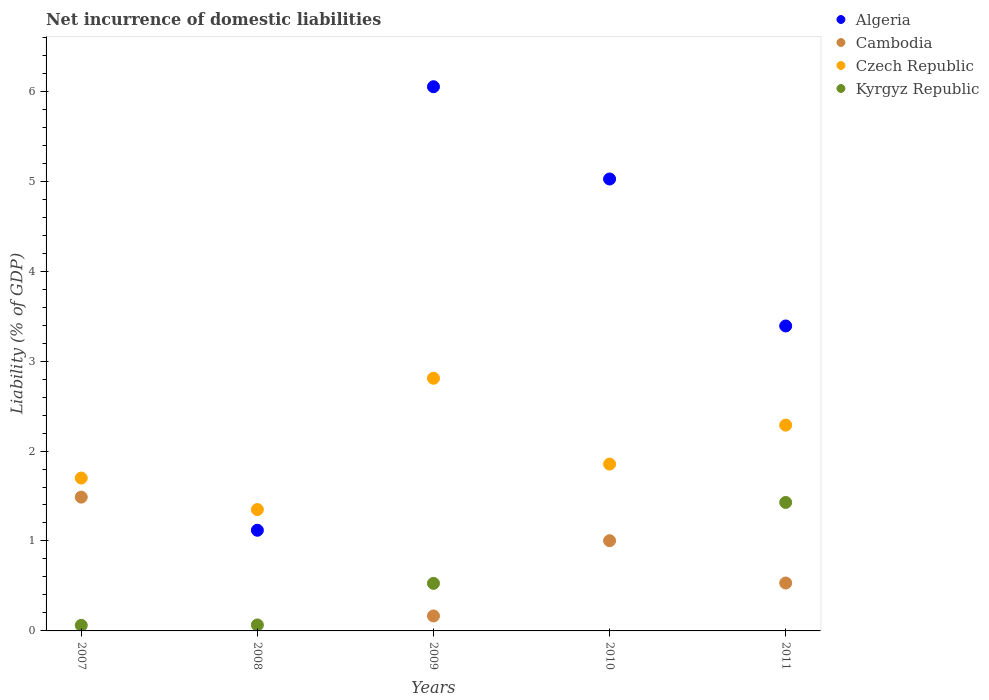How many different coloured dotlines are there?
Make the answer very short. 4. What is the net incurrence of domestic liabilities in Czech Republic in 2009?
Your response must be concise. 2.81. Across all years, what is the maximum net incurrence of domestic liabilities in Kyrgyz Republic?
Make the answer very short. 1.43. Across all years, what is the minimum net incurrence of domestic liabilities in Czech Republic?
Offer a very short reply. 1.35. In which year was the net incurrence of domestic liabilities in Algeria maximum?
Ensure brevity in your answer.  2009. What is the total net incurrence of domestic liabilities in Algeria in the graph?
Give a very brief answer. 15.58. What is the difference between the net incurrence of domestic liabilities in Cambodia in 2007 and that in 2009?
Offer a terse response. 1.32. What is the difference between the net incurrence of domestic liabilities in Kyrgyz Republic in 2008 and the net incurrence of domestic liabilities in Cambodia in 2009?
Offer a terse response. -0.1. What is the average net incurrence of domestic liabilities in Algeria per year?
Offer a very short reply. 3.12. In the year 2009, what is the difference between the net incurrence of domestic liabilities in Cambodia and net incurrence of domestic liabilities in Kyrgyz Republic?
Your answer should be very brief. -0.36. What is the ratio of the net incurrence of domestic liabilities in Cambodia in 2007 to that in 2011?
Make the answer very short. 2.79. What is the difference between the highest and the second highest net incurrence of domestic liabilities in Czech Republic?
Offer a terse response. 0.52. What is the difference between the highest and the lowest net incurrence of domestic liabilities in Cambodia?
Provide a short and direct response. 1.49. How many dotlines are there?
Your answer should be very brief. 4. How many years are there in the graph?
Keep it short and to the point. 5. Are the values on the major ticks of Y-axis written in scientific E-notation?
Provide a short and direct response. No. Does the graph contain any zero values?
Keep it short and to the point. Yes. What is the title of the graph?
Your answer should be very brief. Net incurrence of domestic liabilities. What is the label or title of the Y-axis?
Your answer should be very brief. Liability (% of GDP). What is the Liability (% of GDP) in Algeria in 2007?
Your answer should be very brief. 0. What is the Liability (% of GDP) of Cambodia in 2007?
Your answer should be compact. 1.49. What is the Liability (% of GDP) of Czech Republic in 2007?
Make the answer very short. 1.7. What is the Liability (% of GDP) in Kyrgyz Republic in 2007?
Provide a succinct answer. 0.06. What is the Liability (% of GDP) in Algeria in 2008?
Offer a terse response. 1.12. What is the Liability (% of GDP) in Cambodia in 2008?
Your answer should be compact. 0. What is the Liability (% of GDP) in Czech Republic in 2008?
Keep it short and to the point. 1.35. What is the Liability (% of GDP) in Kyrgyz Republic in 2008?
Your answer should be compact. 0.07. What is the Liability (% of GDP) of Algeria in 2009?
Provide a short and direct response. 6.05. What is the Liability (% of GDP) in Cambodia in 2009?
Make the answer very short. 0.17. What is the Liability (% of GDP) in Czech Republic in 2009?
Offer a terse response. 2.81. What is the Liability (% of GDP) in Kyrgyz Republic in 2009?
Provide a short and direct response. 0.53. What is the Liability (% of GDP) in Algeria in 2010?
Your answer should be compact. 5.02. What is the Liability (% of GDP) of Cambodia in 2010?
Your answer should be very brief. 1. What is the Liability (% of GDP) in Czech Republic in 2010?
Offer a terse response. 1.85. What is the Liability (% of GDP) of Algeria in 2011?
Give a very brief answer. 3.39. What is the Liability (% of GDP) of Cambodia in 2011?
Your answer should be compact. 0.53. What is the Liability (% of GDP) of Czech Republic in 2011?
Your response must be concise. 2.29. What is the Liability (% of GDP) in Kyrgyz Republic in 2011?
Keep it short and to the point. 1.43. Across all years, what is the maximum Liability (% of GDP) of Algeria?
Provide a short and direct response. 6.05. Across all years, what is the maximum Liability (% of GDP) in Cambodia?
Provide a succinct answer. 1.49. Across all years, what is the maximum Liability (% of GDP) in Czech Republic?
Ensure brevity in your answer.  2.81. Across all years, what is the maximum Liability (% of GDP) in Kyrgyz Republic?
Make the answer very short. 1.43. Across all years, what is the minimum Liability (% of GDP) of Algeria?
Your answer should be compact. 0. Across all years, what is the minimum Liability (% of GDP) of Czech Republic?
Offer a terse response. 1.35. What is the total Liability (% of GDP) in Algeria in the graph?
Your answer should be compact. 15.58. What is the total Liability (% of GDP) in Cambodia in the graph?
Your answer should be very brief. 3.19. What is the total Liability (% of GDP) of Czech Republic in the graph?
Provide a short and direct response. 10. What is the total Liability (% of GDP) in Kyrgyz Republic in the graph?
Give a very brief answer. 2.09. What is the difference between the Liability (% of GDP) in Kyrgyz Republic in 2007 and that in 2008?
Keep it short and to the point. -0. What is the difference between the Liability (% of GDP) in Cambodia in 2007 and that in 2009?
Make the answer very short. 1.32. What is the difference between the Liability (% of GDP) in Czech Republic in 2007 and that in 2009?
Make the answer very short. -1.11. What is the difference between the Liability (% of GDP) in Kyrgyz Republic in 2007 and that in 2009?
Ensure brevity in your answer.  -0.47. What is the difference between the Liability (% of GDP) of Cambodia in 2007 and that in 2010?
Provide a short and direct response. 0.48. What is the difference between the Liability (% of GDP) in Czech Republic in 2007 and that in 2010?
Provide a short and direct response. -0.16. What is the difference between the Liability (% of GDP) in Cambodia in 2007 and that in 2011?
Make the answer very short. 0.95. What is the difference between the Liability (% of GDP) of Czech Republic in 2007 and that in 2011?
Offer a terse response. -0.59. What is the difference between the Liability (% of GDP) of Kyrgyz Republic in 2007 and that in 2011?
Make the answer very short. -1.37. What is the difference between the Liability (% of GDP) of Algeria in 2008 and that in 2009?
Offer a very short reply. -4.93. What is the difference between the Liability (% of GDP) of Czech Republic in 2008 and that in 2009?
Your answer should be very brief. -1.46. What is the difference between the Liability (% of GDP) of Kyrgyz Republic in 2008 and that in 2009?
Make the answer very short. -0.46. What is the difference between the Liability (% of GDP) in Algeria in 2008 and that in 2010?
Provide a succinct answer. -3.91. What is the difference between the Liability (% of GDP) of Czech Republic in 2008 and that in 2010?
Provide a short and direct response. -0.51. What is the difference between the Liability (% of GDP) of Algeria in 2008 and that in 2011?
Offer a very short reply. -2.27. What is the difference between the Liability (% of GDP) in Czech Republic in 2008 and that in 2011?
Make the answer very short. -0.94. What is the difference between the Liability (% of GDP) of Kyrgyz Republic in 2008 and that in 2011?
Provide a short and direct response. -1.36. What is the difference between the Liability (% of GDP) of Algeria in 2009 and that in 2010?
Give a very brief answer. 1.03. What is the difference between the Liability (% of GDP) in Cambodia in 2009 and that in 2010?
Offer a terse response. -0.84. What is the difference between the Liability (% of GDP) in Czech Republic in 2009 and that in 2010?
Ensure brevity in your answer.  0.95. What is the difference between the Liability (% of GDP) of Algeria in 2009 and that in 2011?
Ensure brevity in your answer.  2.66. What is the difference between the Liability (% of GDP) of Cambodia in 2009 and that in 2011?
Offer a very short reply. -0.37. What is the difference between the Liability (% of GDP) of Czech Republic in 2009 and that in 2011?
Your response must be concise. 0.52. What is the difference between the Liability (% of GDP) in Kyrgyz Republic in 2009 and that in 2011?
Provide a succinct answer. -0.9. What is the difference between the Liability (% of GDP) in Algeria in 2010 and that in 2011?
Make the answer very short. 1.63. What is the difference between the Liability (% of GDP) in Cambodia in 2010 and that in 2011?
Your answer should be compact. 0.47. What is the difference between the Liability (% of GDP) of Czech Republic in 2010 and that in 2011?
Ensure brevity in your answer.  -0.43. What is the difference between the Liability (% of GDP) of Cambodia in 2007 and the Liability (% of GDP) of Czech Republic in 2008?
Provide a succinct answer. 0.14. What is the difference between the Liability (% of GDP) of Cambodia in 2007 and the Liability (% of GDP) of Kyrgyz Republic in 2008?
Provide a short and direct response. 1.42. What is the difference between the Liability (% of GDP) in Czech Republic in 2007 and the Liability (% of GDP) in Kyrgyz Republic in 2008?
Ensure brevity in your answer.  1.63. What is the difference between the Liability (% of GDP) in Cambodia in 2007 and the Liability (% of GDP) in Czech Republic in 2009?
Your response must be concise. -1.32. What is the difference between the Liability (% of GDP) of Cambodia in 2007 and the Liability (% of GDP) of Kyrgyz Republic in 2009?
Provide a succinct answer. 0.96. What is the difference between the Liability (% of GDP) in Czech Republic in 2007 and the Liability (% of GDP) in Kyrgyz Republic in 2009?
Give a very brief answer. 1.17. What is the difference between the Liability (% of GDP) of Cambodia in 2007 and the Liability (% of GDP) of Czech Republic in 2010?
Your response must be concise. -0.37. What is the difference between the Liability (% of GDP) of Cambodia in 2007 and the Liability (% of GDP) of Czech Republic in 2011?
Give a very brief answer. -0.8. What is the difference between the Liability (% of GDP) in Cambodia in 2007 and the Liability (% of GDP) in Kyrgyz Republic in 2011?
Give a very brief answer. 0.06. What is the difference between the Liability (% of GDP) of Czech Republic in 2007 and the Liability (% of GDP) of Kyrgyz Republic in 2011?
Offer a very short reply. 0.27. What is the difference between the Liability (% of GDP) in Algeria in 2008 and the Liability (% of GDP) in Cambodia in 2009?
Your answer should be compact. 0.95. What is the difference between the Liability (% of GDP) of Algeria in 2008 and the Liability (% of GDP) of Czech Republic in 2009?
Ensure brevity in your answer.  -1.69. What is the difference between the Liability (% of GDP) in Algeria in 2008 and the Liability (% of GDP) in Kyrgyz Republic in 2009?
Offer a terse response. 0.59. What is the difference between the Liability (% of GDP) of Czech Republic in 2008 and the Liability (% of GDP) of Kyrgyz Republic in 2009?
Keep it short and to the point. 0.82. What is the difference between the Liability (% of GDP) of Algeria in 2008 and the Liability (% of GDP) of Cambodia in 2010?
Make the answer very short. 0.12. What is the difference between the Liability (% of GDP) of Algeria in 2008 and the Liability (% of GDP) of Czech Republic in 2010?
Provide a short and direct response. -0.74. What is the difference between the Liability (% of GDP) of Algeria in 2008 and the Liability (% of GDP) of Cambodia in 2011?
Give a very brief answer. 0.59. What is the difference between the Liability (% of GDP) of Algeria in 2008 and the Liability (% of GDP) of Czech Republic in 2011?
Your answer should be very brief. -1.17. What is the difference between the Liability (% of GDP) in Algeria in 2008 and the Liability (% of GDP) in Kyrgyz Republic in 2011?
Provide a succinct answer. -0.31. What is the difference between the Liability (% of GDP) of Czech Republic in 2008 and the Liability (% of GDP) of Kyrgyz Republic in 2011?
Provide a succinct answer. -0.08. What is the difference between the Liability (% of GDP) of Algeria in 2009 and the Liability (% of GDP) of Cambodia in 2010?
Offer a very short reply. 5.05. What is the difference between the Liability (% of GDP) in Algeria in 2009 and the Liability (% of GDP) in Czech Republic in 2010?
Make the answer very short. 4.2. What is the difference between the Liability (% of GDP) of Cambodia in 2009 and the Liability (% of GDP) of Czech Republic in 2010?
Provide a short and direct response. -1.69. What is the difference between the Liability (% of GDP) of Algeria in 2009 and the Liability (% of GDP) of Cambodia in 2011?
Keep it short and to the point. 5.52. What is the difference between the Liability (% of GDP) in Algeria in 2009 and the Liability (% of GDP) in Czech Republic in 2011?
Keep it short and to the point. 3.76. What is the difference between the Liability (% of GDP) of Algeria in 2009 and the Liability (% of GDP) of Kyrgyz Republic in 2011?
Your answer should be very brief. 4.62. What is the difference between the Liability (% of GDP) of Cambodia in 2009 and the Liability (% of GDP) of Czech Republic in 2011?
Provide a short and direct response. -2.12. What is the difference between the Liability (% of GDP) of Cambodia in 2009 and the Liability (% of GDP) of Kyrgyz Republic in 2011?
Offer a very short reply. -1.26. What is the difference between the Liability (% of GDP) in Czech Republic in 2009 and the Liability (% of GDP) in Kyrgyz Republic in 2011?
Offer a very short reply. 1.38. What is the difference between the Liability (% of GDP) in Algeria in 2010 and the Liability (% of GDP) in Cambodia in 2011?
Your answer should be compact. 4.49. What is the difference between the Liability (% of GDP) in Algeria in 2010 and the Liability (% of GDP) in Czech Republic in 2011?
Your answer should be very brief. 2.74. What is the difference between the Liability (% of GDP) in Algeria in 2010 and the Liability (% of GDP) in Kyrgyz Republic in 2011?
Your answer should be compact. 3.6. What is the difference between the Liability (% of GDP) of Cambodia in 2010 and the Liability (% of GDP) of Czech Republic in 2011?
Ensure brevity in your answer.  -1.29. What is the difference between the Liability (% of GDP) in Cambodia in 2010 and the Liability (% of GDP) in Kyrgyz Republic in 2011?
Give a very brief answer. -0.43. What is the difference between the Liability (% of GDP) of Czech Republic in 2010 and the Liability (% of GDP) of Kyrgyz Republic in 2011?
Your response must be concise. 0.43. What is the average Liability (% of GDP) in Algeria per year?
Offer a terse response. 3.12. What is the average Liability (% of GDP) of Cambodia per year?
Give a very brief answer. 0.64. What is the average Liability (% of GDP) of Czech Republic per year?
Give a very brief answer. 2. What is the average Liability (% of GDP) of Kyrgyz Republic per year?
Offer a terse response. 0.42. In the year 2007, what is the difference between the Liability (% of GDP) in Cambodia and Liability (% of GDP) in Czech Republic?
Provide a succinct answer. -0.21. In the year 2007, what is the difference between the Liability (% of GDP) in Cambodia and Liability (% of GDP) in Kyrgyz Republic?
Provide a succinct answer. 1.43. In the year 2007, what is the difference between the Liability (% of GDP) in Czech Republic and Liability (% of GDP) in Kyrgyz Republic?
Your answer should be very brief. 1.64. In the year 2008, what is the difference between the Liability (% of GDP) of Algeria and Liability (% of GDP) of Czech Republic?
Offer a terse response. -0.23. In the year 2008, what is the difference between the Liability (% of GDP) of Algeria and Liability (% of GDP) of Kyrgyz Republic?
Provide a short and direct response. 1.05. In the year 2008, what is the difference between the Liability (% of GDP) in Czech Republic and Liability (% of GDP) in Kyrgyz Republic?
Give a very brief answer. 1.28. In the year 2009, what is the difference between the Liability (% of GDP) in Algeria and Liability (% of GDP) in Cambodia?
Provide a short and direct response. 5.88. In the year 2009, what is the difference between the Liability (% of GDP) in Algeria and Liability (% of GDP) in Czech Republic?
Give a very brief answer. 3.24. In the year 2009, what is the difference between the Liability (% of GDP) in Algeria and Liability (% of GDP) in Kyrgyz Republic?
Your response must be concise. 5.52. In the year 2009, what is the difference between the Liability (% of GDP) of Cambodia and Liability (% of GDP) of Czech Republic?
Offer a terse response. -2.64. In the year 2009, what is the difference between the Liability (% of GDP) in Cambodia and Liability (% of GDP) in Kyrgyz Republic?
Make the answer very short. -0.36. In the year 2009, what is the difference between the Liability (% of GDP) of Czech Republic and Liability (% of GDP) of Kyrgyz Republic?
Make the answer very short. 2.28. In the year 2010, what is the difference between the Liability (% of GDP) in Algeria and Liability (% of GDP) in Cambodia?
Give a very brief answer. 4.02. In the year 2010, what is the difference between the Liability (% of GDP) in Algeria and Liability (% of GDP) in Czech Republic?
Your answer should be compact. 3.17. In the year 2010, what is the difference between the Liability (% of GDP) of Cambodia and Liability (% of GDP) of Czech Republic?
Offer a very short reply. -0.85. In the year 2011, what is the difference between the Liability (% of GDP) of Algeria and Liability (% of GDP) of Cambodia?
Ensure brevity in your answer.  2.86. In the year 2011, what is the difference between the Liability (% of GDP) in Algeria and Liability (% of GDP) in Czech Republic?
Your answer should be compact. 1.1. In the year 2011, what is the difference between the Liability (% of GDP) in Algeria and Liability (% of GDP) in Kyrgyz Republic?
Keep it short and to the point. 1.96. In the year 2011, what is the difference between the Liability (% of GDP) of Cambodia and Liability (% of GDP) of Czech Republic?
Your answer should be compact. -1.76. In the year 2011, what is the difference between the Liability (% of GDP) in Cambodia and Liability (% of GDP) in Kyrgyz Republic?
Give a very brief answer. -0.9. In the year 2011, what is the difference between the Liability (% of GDP) of Czech Republic and Liability (% of GDP) of Kyrgyz Republic?
Offer a terse response. 0.86. What is the ratio of the Liability (% of GDP) of Czech Republic in 2007 to that in 2008?
Provide a succinct answer. 1.26. What is the ratio of the Liability (% of GDP) in Kyrgyz Republic in 2007 to that in 2008?
Provide a succinct answer. 0.93. What is the ratio of the Liability (% of GDP) of Cambodia in 2007 to that in 2009?
Your answer should be compact. 8.93. What is the ratio of the Liability (% of GDP) of Czech Republic in 2007 to that in 2009?
Provide a succinct answer. 0.6. What is the ratio of the Liability (% of GDP) of Kyrgyz Republic in 2007 to that in 2009?
Provide a succinct answer. 0.12. What is the ratio of the Liability (% of GDP) of Cambodia in 2007 to that in 2010?
Your answer should be very brief. 1.48. What is the ratio of the Liability (% of GDP) in Czech Republic in 2007 to that in 2010?
Make the answer very short. 0.92. What is the ratio of the Liability (% of GDP) in Cambodia in 2007 to that in 2011?
Ensure brevity in your answer.  2.79. What is the ratio of the Liability (% of GDP) in Czech Republic in 2007 to that in 2011?
Offer a terse response. 0.74. What is the ratio of the Liability (% of GDP) in Kyrgyz Republic in 2007 to that in 2011?
Ensure brevity in your answer.  0.04. What is the ratio of the Liability (% of GDP) in Algeria in 2008 to that in 2009?
Make the answer very short. 0.18. What is the ratio of the Liability (% of GDP) in Czech Republic in 2008 to that in 2009?
Provide a succinct answer. 0.48. What is the ratio of the Liability (% of GDP) in Kyrgyz Republic in 2008 to that in 2009?
Your response must be concise. 0.13. What is the ratio of the Liability (% of GDP) of Algeria in 2008 to that in 2010?
Make the answer very short. 0.22. What is the ratio of the Liability (% of GDP) of Czech Republic in 2008 to that in 2010?
Your answer should be compact. 0.73. What is the ratio of the Liability (% of GDP) of Algeria in 2008 to that in 2011?
Your answer should be compact. 0.33. What is the ratio of the Liability (% of GDP) in Czech Republic in 2008 to that in 2011?
Provide a succinct answer. 0.59. What is the ratio of the Liability (% of GDP) of Kyrgyz Republic in 2008 to that in 2011?
Your response must be concise. 0.05. What is the ratio of the Liability (% of GDP) in Algeria in 2009 to that in 2010?
Keep it short and to the point. 1.2. What is the ratio of the Liability (% of GDP) of Cambodia in 2009 to that in 2010?
Make the answer very short. 0.17. What is the ratio of the Liability (% of GDP) in Czech Republic in 2009 to that in 2010?
Your response must be concise. 1.51. What is the ratio of the Liability (% of GDP) in Algeria in 2009 to that in 2011?
Make the answer very short. 1.78. What is the ratio of the Liability (% of GDP) of Cambodia in 2009 to that in 2011?
Give a very brief answer. 0.31. What is the ratio of the Liability (% of GDP) of Czech Republic in 2009 to that in 2011?
Offer a very short reply. 1.23. What is the ratio of the Liability (% of GDP) in Kyrgyz Republic in 2009 to that in 2011?
Make the answer very short. 0.37. What is the ratio of the Liability (% of GDP) of Algeria in 2010 to that in 2011?
Keep it short and to the point. 1.48. What is the ratio of the Liability (% of GDP) in Cambodia in 2010 to that in 2011?
Give a very brief answer. 1.88. What is the ratio of the Liability (% of GDP) of Czech Republic in 2010 to that in 2011?
Keep it short and to the point. 0.81. What is the difference between the highest and the second highest Liability (% of GDP) in Algeria?
Offer a terse response. 1.03. What is the difference between the highest and the second highest Liability (% of GDP) of Cambodia?
Provide a short and direct response. 0.48. What is the difference between the highest and the second highest Liability (% of GDP) in Czech Republic?
Your response must be concise. 0.52. What is the difference between the highest and the second highest Liability (% of GDP) of Kyrgyz Republic?
Your answer should be very brief. 0.9. What is the difference between the highest and the lowest Liability (% of GDP) of Algeria?
Give a very brief answer. 6.05. What is the difference between the highest and the lowest Liability (% of GDP) of Cambodia?
Your response must be concise. 1.49. What is the difference between the highest and the lowest Liability (% of GDP) in Czech Republic?
Your answer should be very brief. 1.46. What is the difference between the highest and the lowest Liability (% of GDP) in Kyrgyz Republic?
Keep it short and to the point. 1.43. 